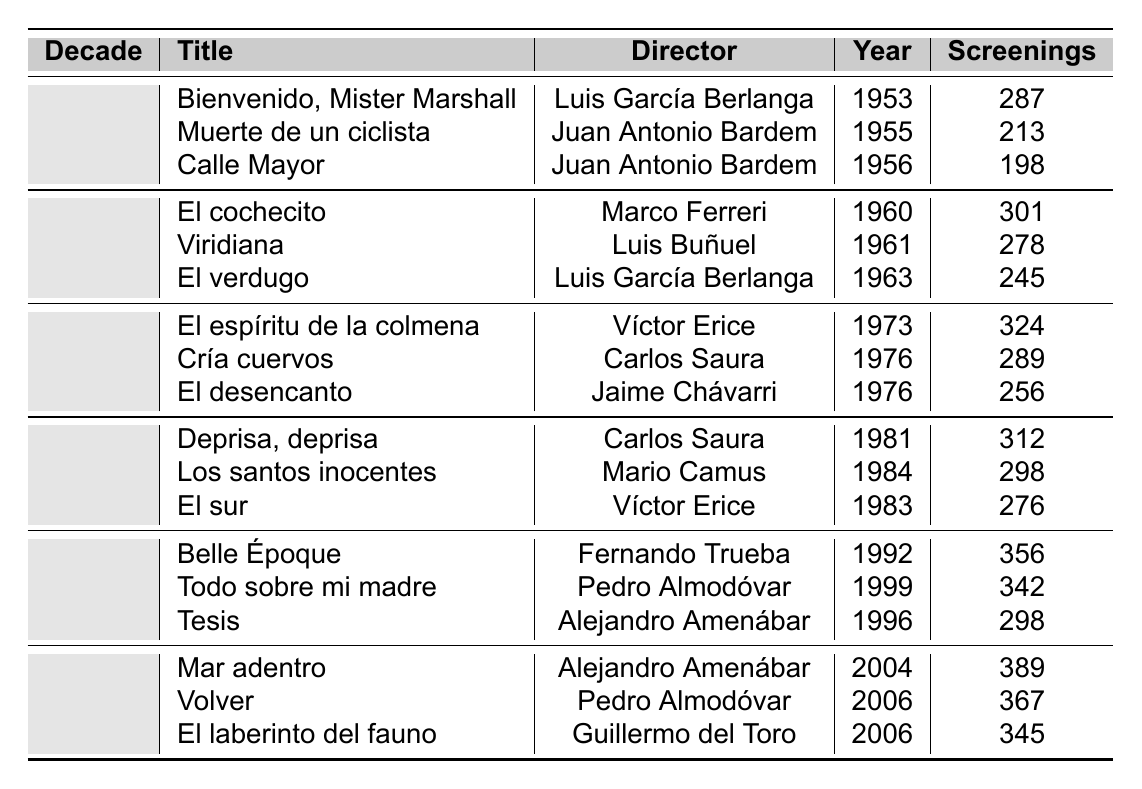What was the most popular film screened in the 1990s? The most popular film screened in the 1990s is "Belle Époque," which had 356 screenings.
Answer: Belle Époque Which film had the highest number of screenings in the 2000s? "Mar adentro" had the highest number of screenings in the 2000s with 389 screenings.
Answer: Mar adentro How many screenings did "El cochecito" have? "El cochecito," directed by Marco Ferreri, had 301 screenings.
Answer: 301 In which decade was "Viridiana" screened, and how many times? "Viridiana" was screened in the 1960s and had 278 screenings.
Answer: 1960s, 278 Which director has the most films listed in the table? Pedro Almodóvar has the most films listed, with two films: "Todo sobre mi madre" and "Volver."
Answer: Pedro Almodóvar What is the total number of screenings for films in the 1980s? The total number of screenings for films in the 1980s is calculated as follows: 312 + 298 + 276 = 886.
Answer: 886 Is "Calle Mayor" more popular than "Muerte de un ciclista"? "Calle Mayor" had 198 screenings while "Muerte de un ciclista" had 213, so "Calle Mayor" is less popular.
Answer: No What was the average number of screenings for films in the 1970s? To find the average for the 1970s, add the screenings: 324 + 289 + 256 = 869. Then divide by 3 (the number of films): 869 / 3 = 289.67.
Answer: 289.67 How many screenings did films directed by Carlos Saura receive in total? The total screenings for Carlos Saura's films are 312 (Deprisa, deprisa) + 289 (Cría cuervos) = 601.
Answer: 601 Which film from the 1950s had the least screenings? "Calle Mayor" had the least screenings in the 1950s, with 198 screenings.
Answer: Calle Mayor Which decade had the highest total screenings for all films combined? We calculate total screenings by decade: 1950s (698) + 1960s (824) + 1970s (869) + 1980s (886) + 1990s (996) + 2000s (1101). The 2000s had the highest total with 1101 screenings.
Answer: 2000s 